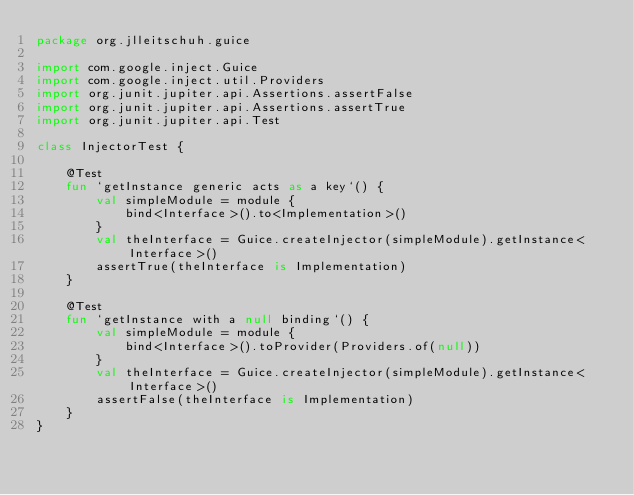<code> <loc_0><loc_0><loc_500><loc_500><_Kotlin_>package org.jlleitschuh.guice

import com.google.inject.Guice
import com.google.inject.util.Providers
import org.junit.jupiter.api.Assertions.assertFalse
import org.junit.jupiter.api.Assertions.assertTrue
import org.junit.jupiter.api.Test

class InjectorTest {

    @Test
    fun `getInstance generic acts as a key`() {
        val simpleModule = module {
            bind<Interface>().to<Implementation>()
        }
        val theInterface = Guice.createInjector(simpleModule).getInstance<Interface>()
        assertTrue(theInterface is Implementation)
    }

    @Test
    fun `getInstance with a null binding`() {
        val simpleModule = module {
            bind<Interface>().toProvider(Providers.of(null))
        }
        val theInterface = Guice.createInjector(simpleModule).getInstance<Interface>()
        assertFalse(theInterface is Implementation)
    }
}
</code> 